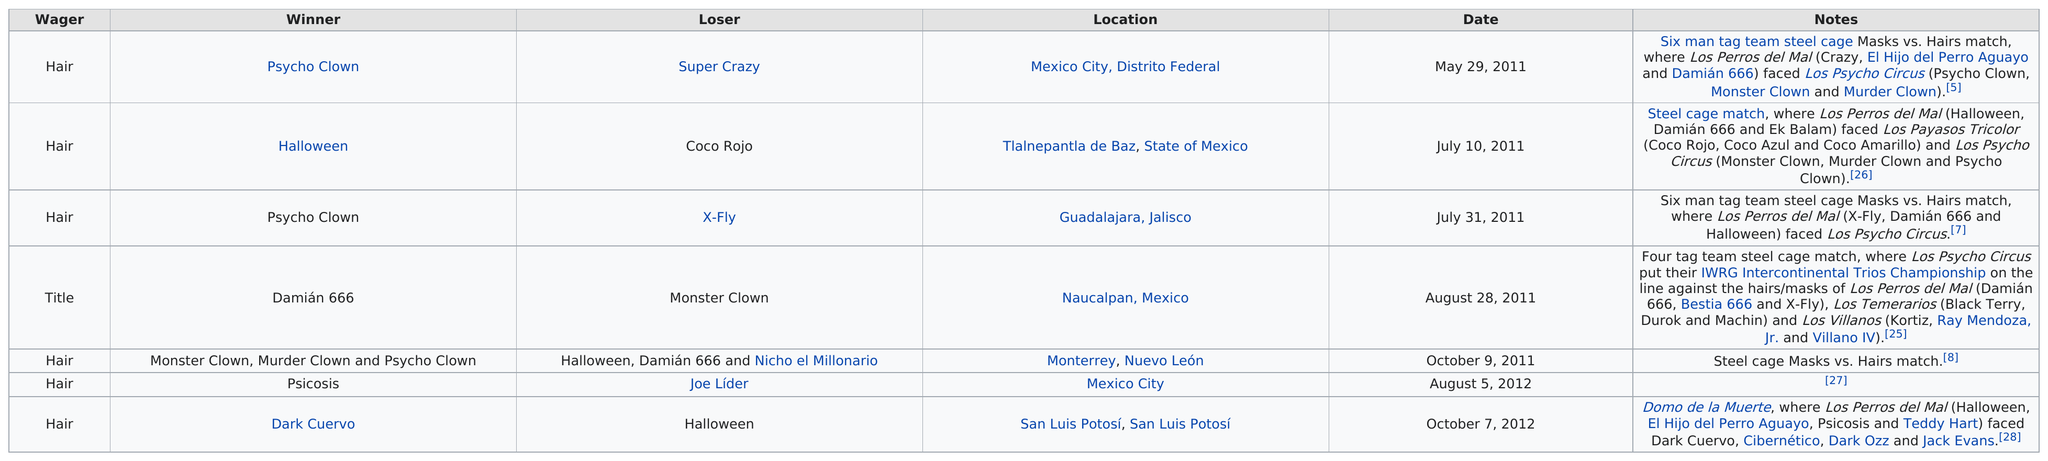Give some essential details in this illustration. On October 7, 2012, the game between the Dark Crow and Halloween was held, with the Dark Crow winning and Halloween losing. Psycho Clown, who has won at least two times, is the current reigning champion in Lucha Underground. In 2011, there were 5 matches. The match between Psycho Clown and Super Crazy was earlier, while the match between Psycho Clown and X-Fly has yet to occur. There is a winner whose name contains numbers, specifically Damián, and the number in his name is 666. 